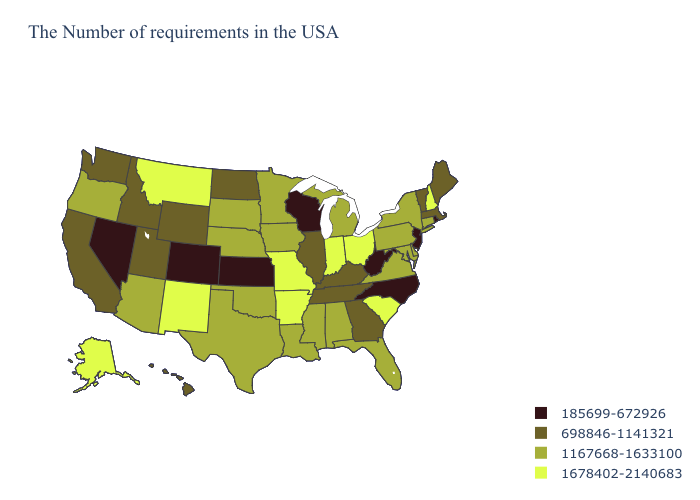Among the states that border Delaware , which have the highest value?
Write a very short answer. Maryland, Pennsylvania. What is the value of Nebraska?
Short answer required. 1167668-1633100. Which states hav the highest value in the Northeast?
Write a very short answer. New Hampshire. What is the lowest value in the MidWest?
Answer briefly. 185699-672926. What is the lowest value in the USA?
Give a very brief answer. 185699-672926. Is the legend a continuous bar?
Short answer required. No. Name the states that have a value in the range 698846-1141321?
Concise answer only. Maine, Massachusetts, Vermont, Georgia, Kentucky, Tennessee, Illinois, North Dakota, Wyoming, Utah, Idaho, California, Washington, Hawaii. Among the states that border Oklahoma , which have the highest value?
Give a very brief answer. Missouri, Arkansas, New Mexico. Is the legend a continuous bar?
Give a very brief answer. No. Among the states that border Nebraska , which have the highest value?
Give a very brief answer. Missouri. Among the states that border Kansas , which have the lowest value?
Answer briefly. Colorado. Name the states that have a value in the range 185699-672926?
Answer briefly. Rhode Island, New Jersey, North Carolina, West Virginia, Wisconsin, Kansas, Colorado, Nevada. What is the value of Utah?
Be succinct. 698846-1141321. Is the legend a continuous bar?
Give a very brief answer. No. What is the value of California?
Keep it brief. 698846-1141321. 